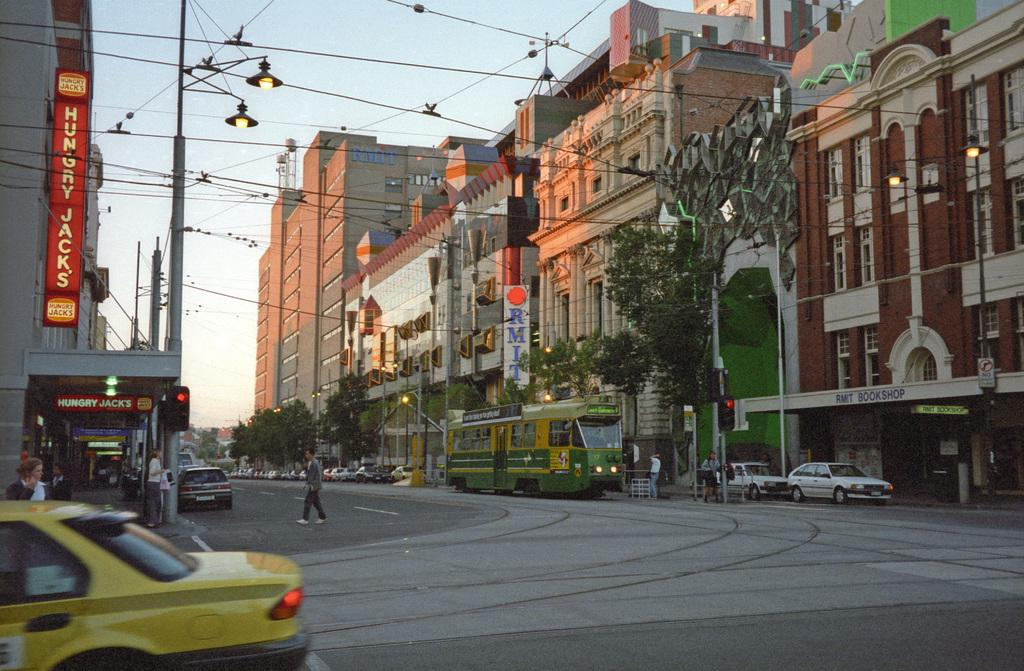<image>
Present a compact description of the photo's key features. Hungry Jack's is the name glowing from the sign above the eatery. 